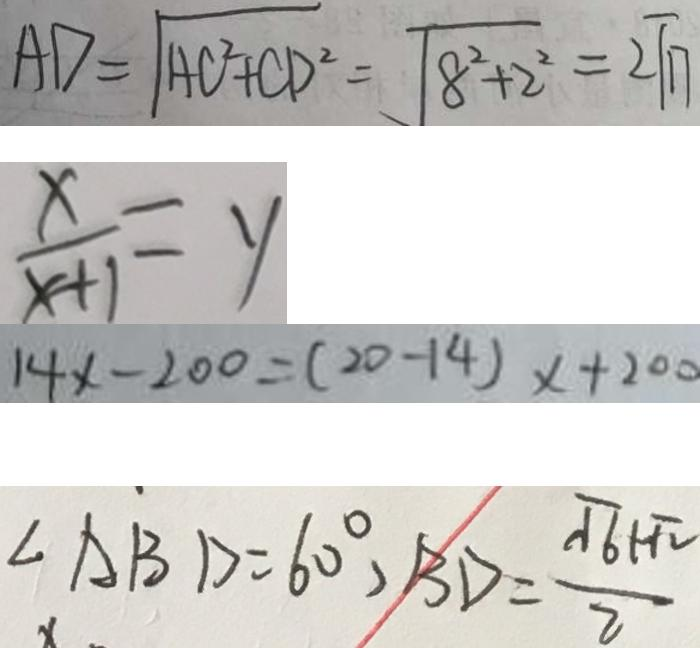<formula> <loc_0><loc_0><loc_500><loc_500>A D = \sqrt { A C ^ { 2 } + C D ^ { 2 } } = \sqrt { 8 ^ { 2 } + 2 ^ { 2 } } = 2 \sqrt { 1 7 } 
 \frac { x } { x + 1 } = y 
 1 4 x - 2 0 0 = ( 2 0 - 1 4 ) x + 2 0 0 
 \angle A B D = 6 0 ^ { \circ } , B D = \frac { \sqrt { 6 } + \sqrt { 2 } } { 2 }</formula> 